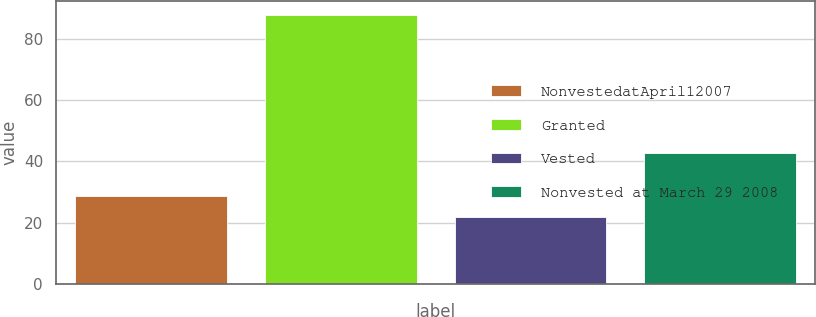<chart> <loc_0><loc_0><loc_500><loc_500><bar_chart><fcel>NonvestedatApril12007<fcel>Granted<fcel>Vested<fcel>Nonvested at March 29 2008<nl><fcel>28.56<fcel>87.85<fcel>21.97<fcel>42.6<nl></chart> 